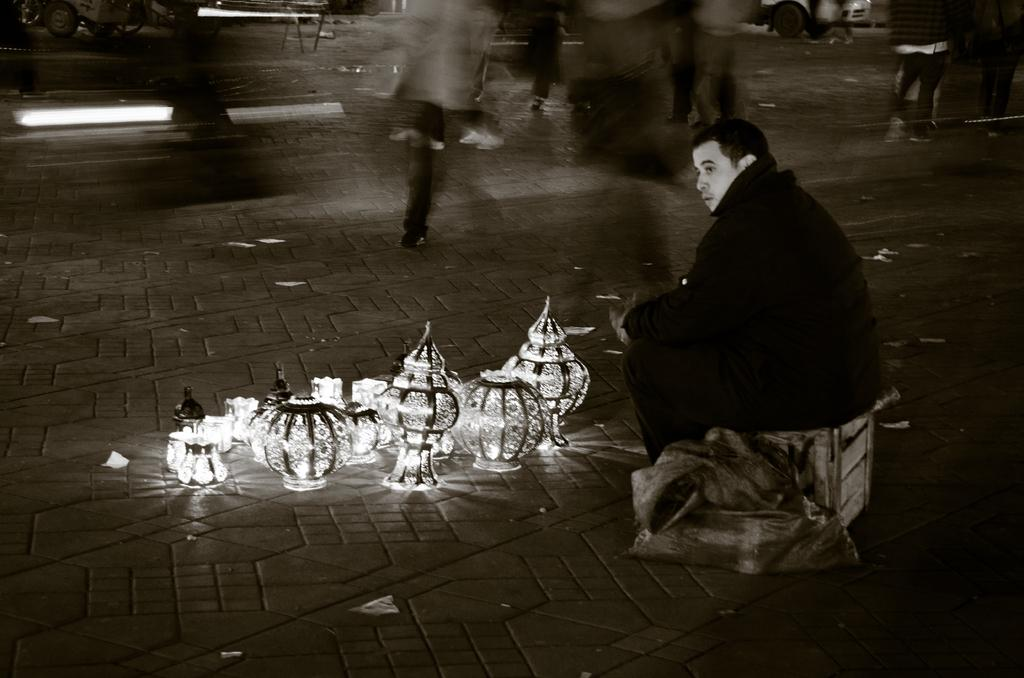Who is present in the image? There is a man in the image. What is the man sitting on? The man is sitting on a wooden box. What can be seen in front of the man? There are objects on a platform in front of the man. Can you describe the background of the image? The background of the image is blurred. What type of leather is covering the trucks in the image? There are no trucks present in the image, so there is no leather to be covered. 